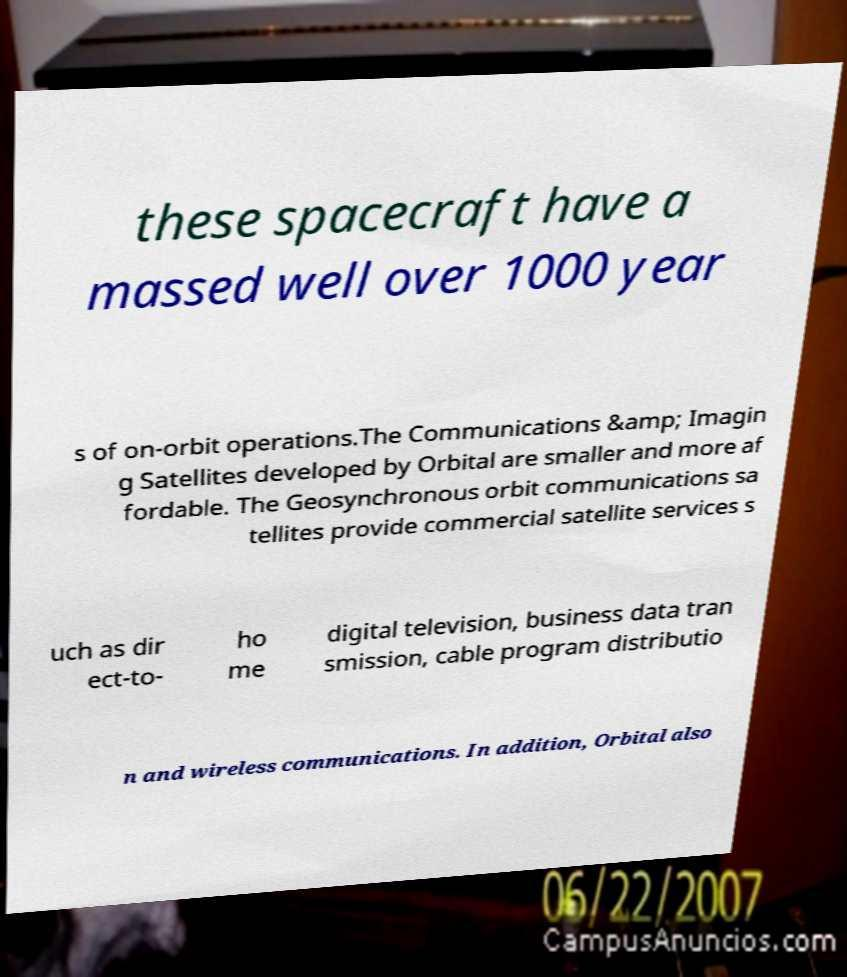Please identify and transcribe the text found in this image. these spacecraft have a massed well over 1000 year s of on-orbit operations.The Communications &amp; Imagin g Satellites developed by Orbital are smaller and more af fordable. The Geosynchronous orbit communications sa tellites provide commercial satellite services s uch as dir ect-to- ho me digital television, business data tran smission, cable program distributio n and wireless communications. In addition, Orbital also 